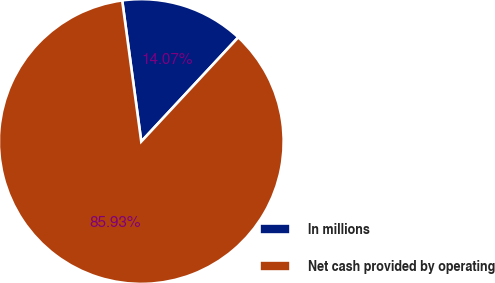Convert chart. <chart><loc_0><loc_0><loc_500><loc_500><pie_chart><fcel>In millions<fcel>Net cash provided by operating<nl><fcel>14.07%<fcel>85.93%<nl></chart> 